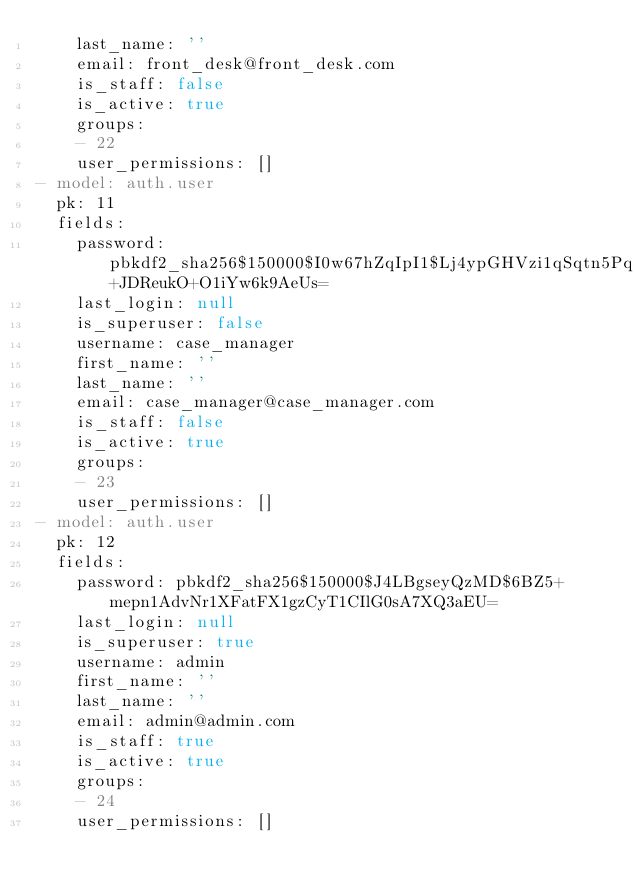<code> <loc_0><loc_0><loc_500><loc_500><_YAML_>    last_name: ''
    email: front_desk@front_desk.com
    is_staff: false
    is_active: true
    groups:
    - 22
    user_permissions: []
- model: auth.user
  pk: 11
  fields:
    password: pbkdf2_sha256$150000$I0w67hZqIpI1$Lj4ypGHVzi1qSqtn5PqSC6+JDReukO+O1iYw6k9AeUs=
    last_login: null
    is_superuser: false
    username: case_manager
    first_name: ''
    last_name: ''
    email: case_manager@case_manager.com
    is_staff: false
    is_active: true
    groups:
    - 23
    user_permissions: []
- model: auth.user
  pk: 12
  fields:
    password: pbkdf2_sha256$150000$J4LBgseyQzMD$6BZ5+mepn1AdvNr1XFatFX1gzCyT1CIlG0sA7XQ3aEU=
    last_login: null
    is_superuser: true
    username: admin
    first_name: ''
    last_name: ''
    email: admin@admin.com
    is_staff: true
    is_active: true
    groups:
    - 24
    user_permissions: []
</code> 